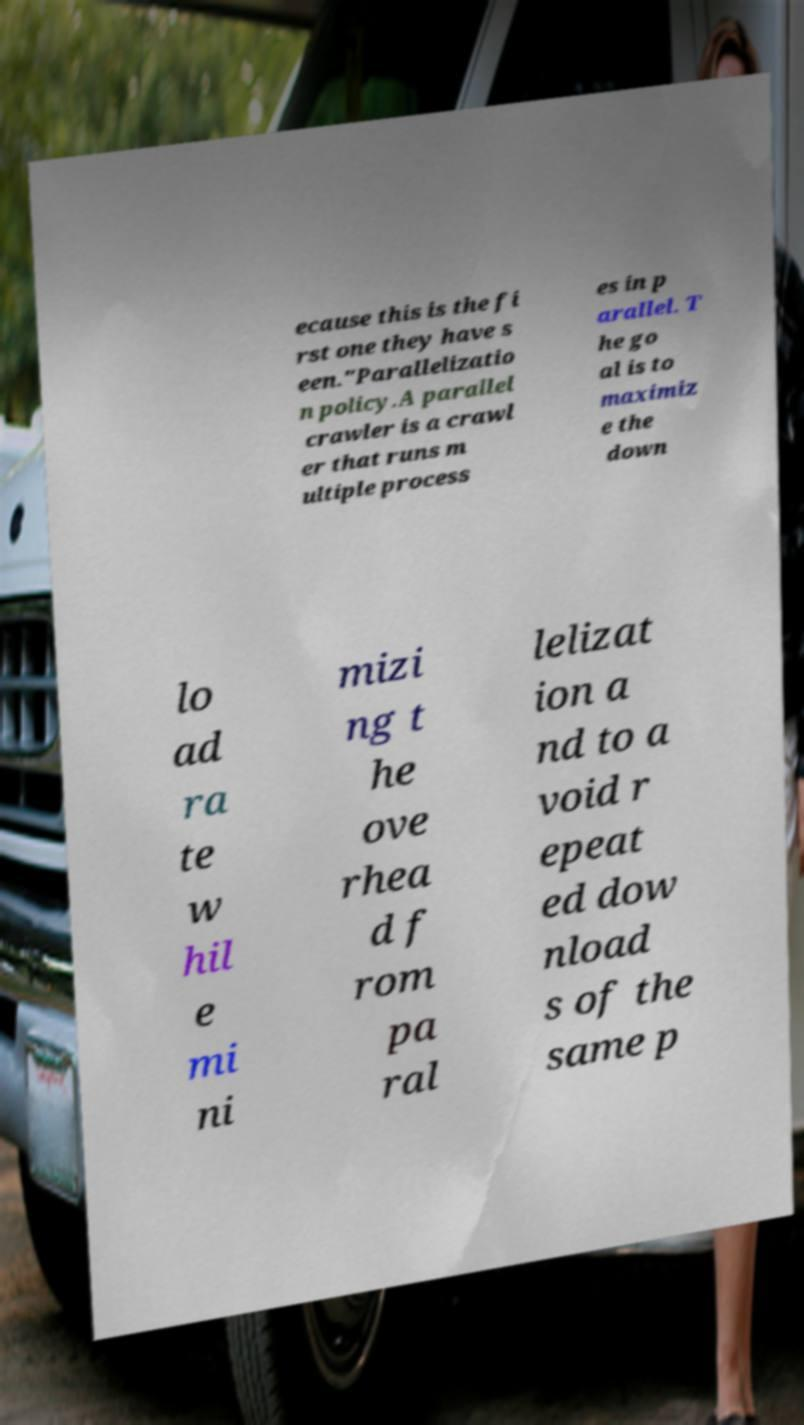There's text embedded in this image that I need extracted. Can you transcribe it verbatim? ecause this is the fi rst one they have s een."Parallelizatio n policy.A parallel crawler is a crawl er that runs m ultiple process es in p arallel. T he go al is to maximiz e the down lo ad ra te w hil e mi ni mizi ng t he ove rhea d f rom pa ral lelizat ion a nd to a void r epeat ed dow nload s of the same p 